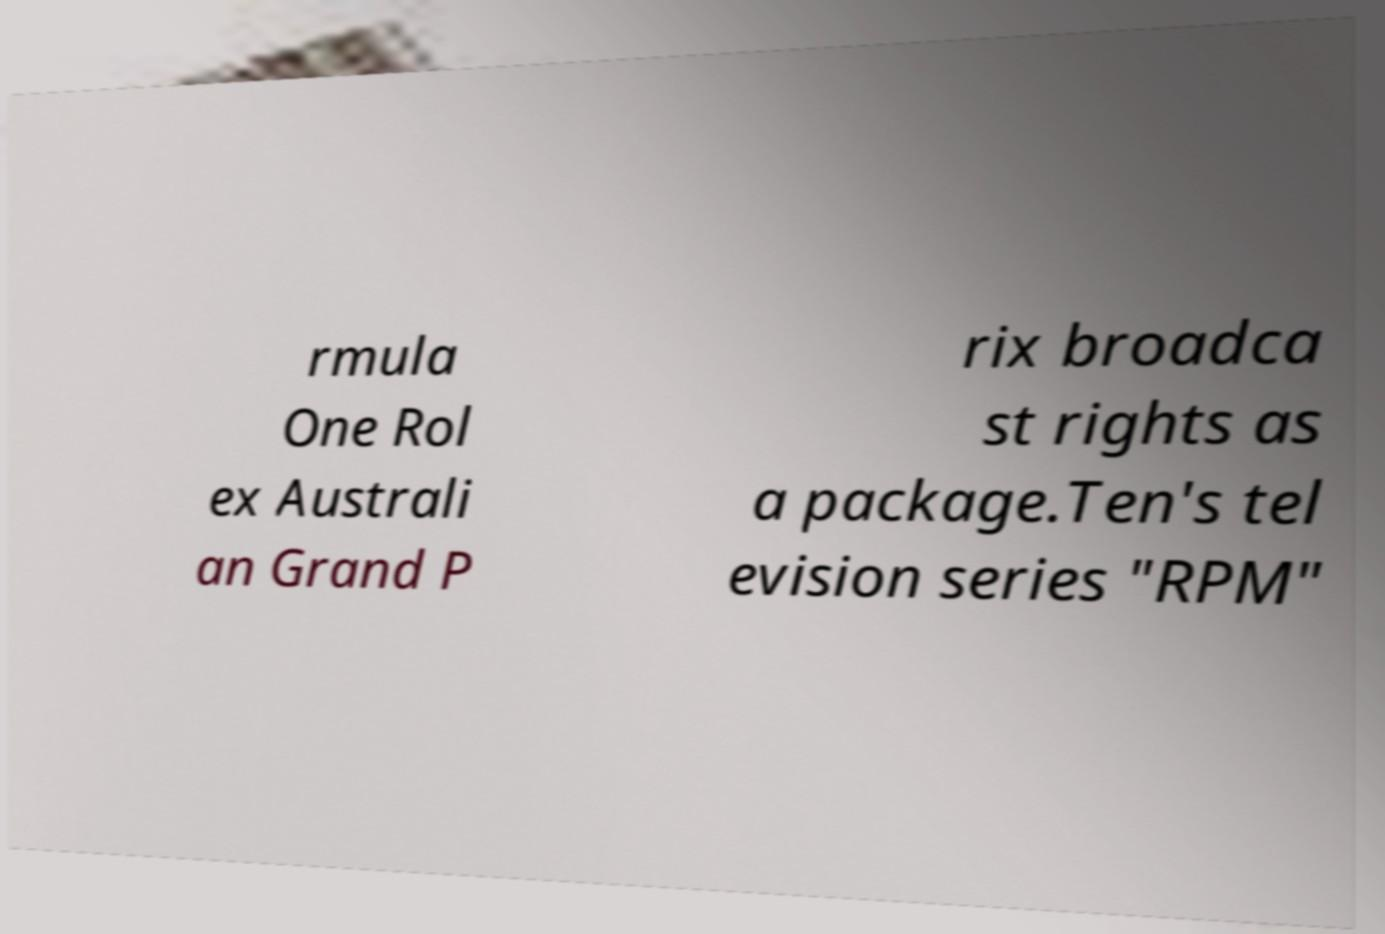Can you read and provide the text displayed in the image?This photo seems to have some interesting text. Can you extract and type it out for me? rmula One Rol ex Australi an Grand P rix broadca st rights as a package.Ten's tel evision series "RPM" 